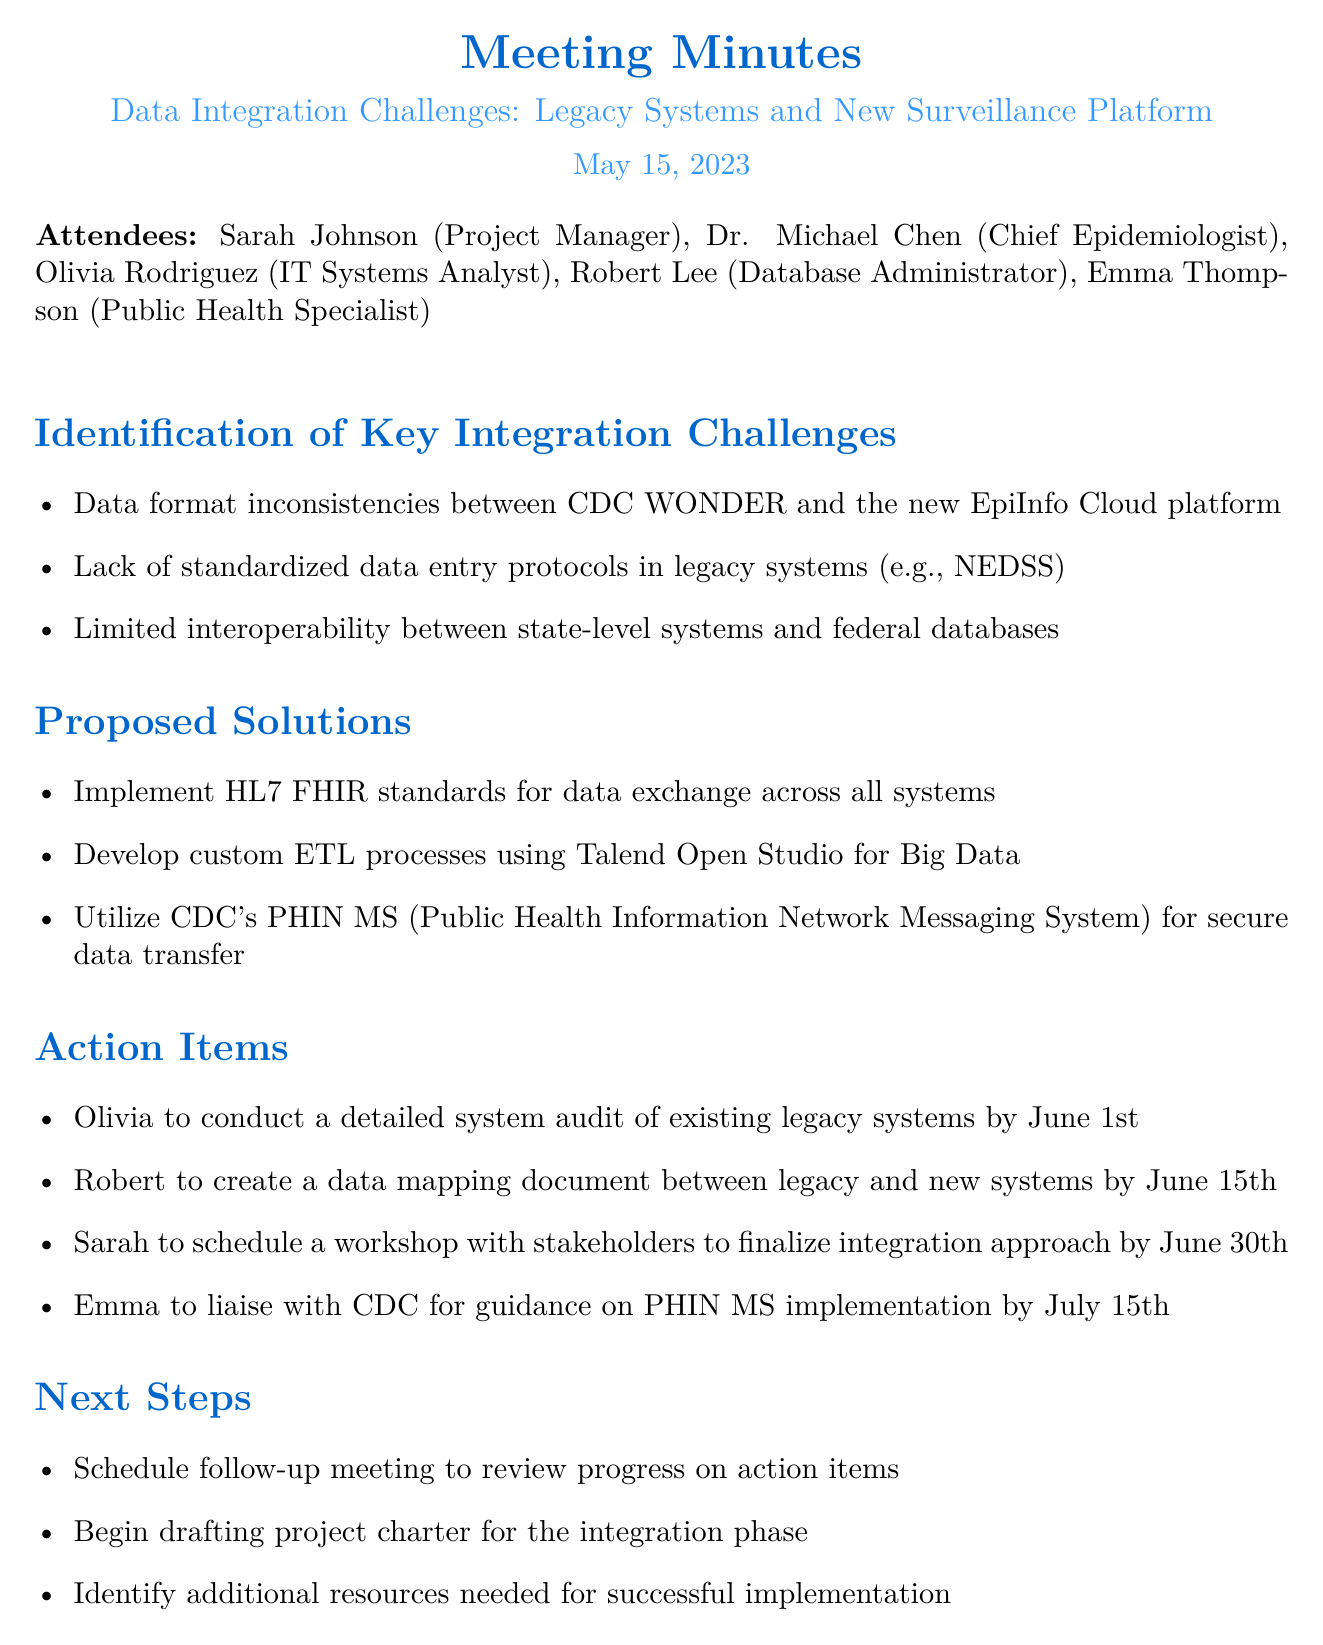What is the meeting title? The meeting title is stated at the beginning of the document.
Answer: Data Integration Challenges: Legacy Systems and New Surveillance Platform Who is the Chief Epidemiologist? The document lists the attendees and their titles clearly.
Answer: Dr. Michael Chen What is the date of the meeting? The date of the meeting is mentioned in the document header.
Answer: May 15, 2023 What is one proposed solution for data integration? The proposed solutions are listed under a specific section in the document.
Answer: Implement HL7 FHIR standards for data exchange across all systems Who is responsible for conducting a system audit? The action items specify who is responsible for each task.
Answer: Olivia What is the deadline for the data mapping document? Each action item includes a specific deadline.
Answer: June 15th What is one key integration challenge identified? The challenges are listed in a section dedicated to key issues.
Answer: Data format inconsistencies between CDC WONDER and the new EpiInfo Cloud platform What is the next step after the follow-up meeting? The document outlines the next steps clearly after the meeting section.
Answer: Begin drafting project charter for the integration phase 